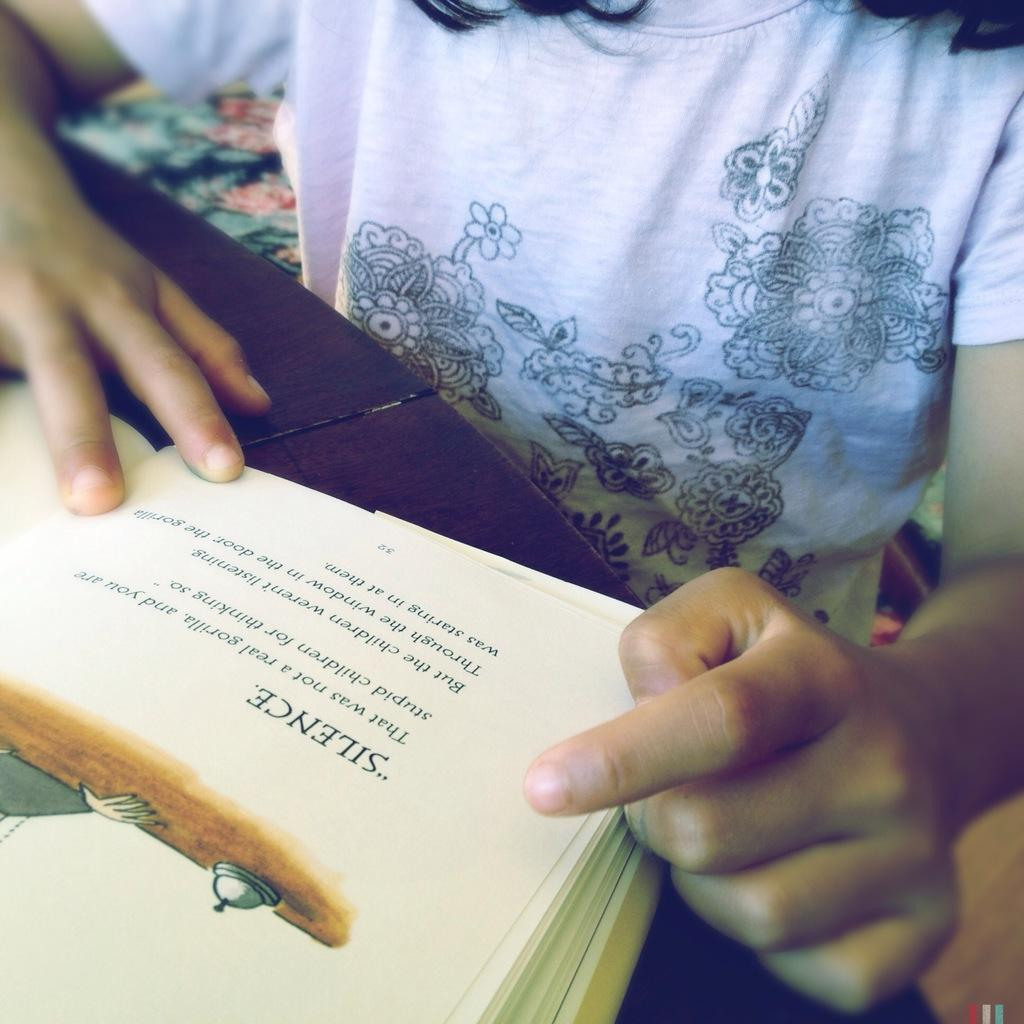<image>
Relay a brief, clear account of the picture shown. a person reading a book with the word silence in it 